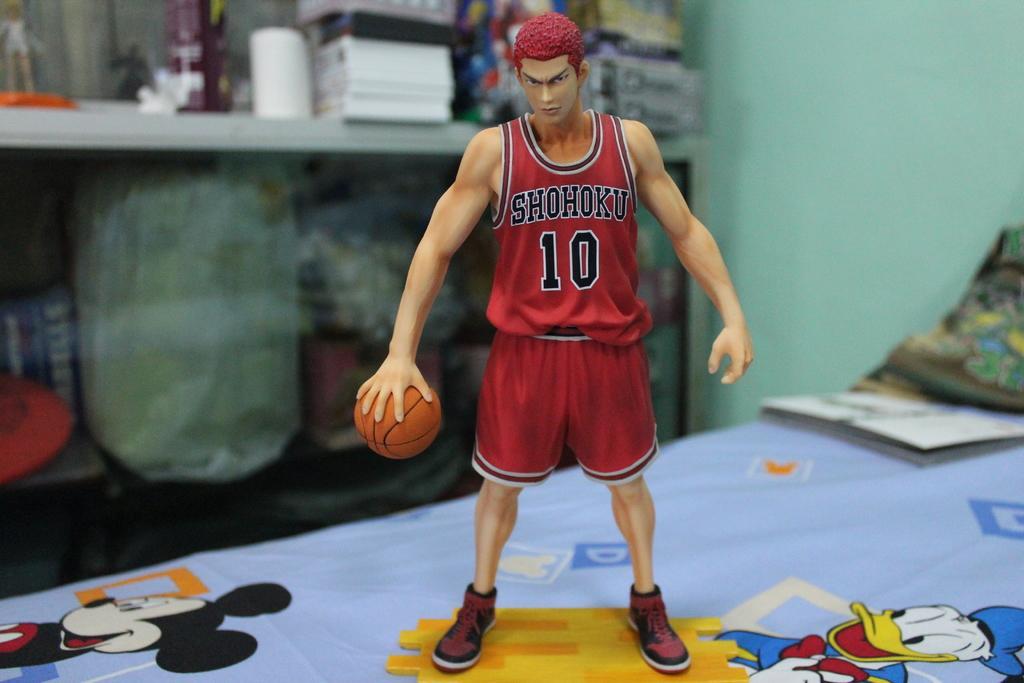In one or two sentences, can you explain what this image depicts? In this image, i can see a toy holding basketball and the background is blurry. 